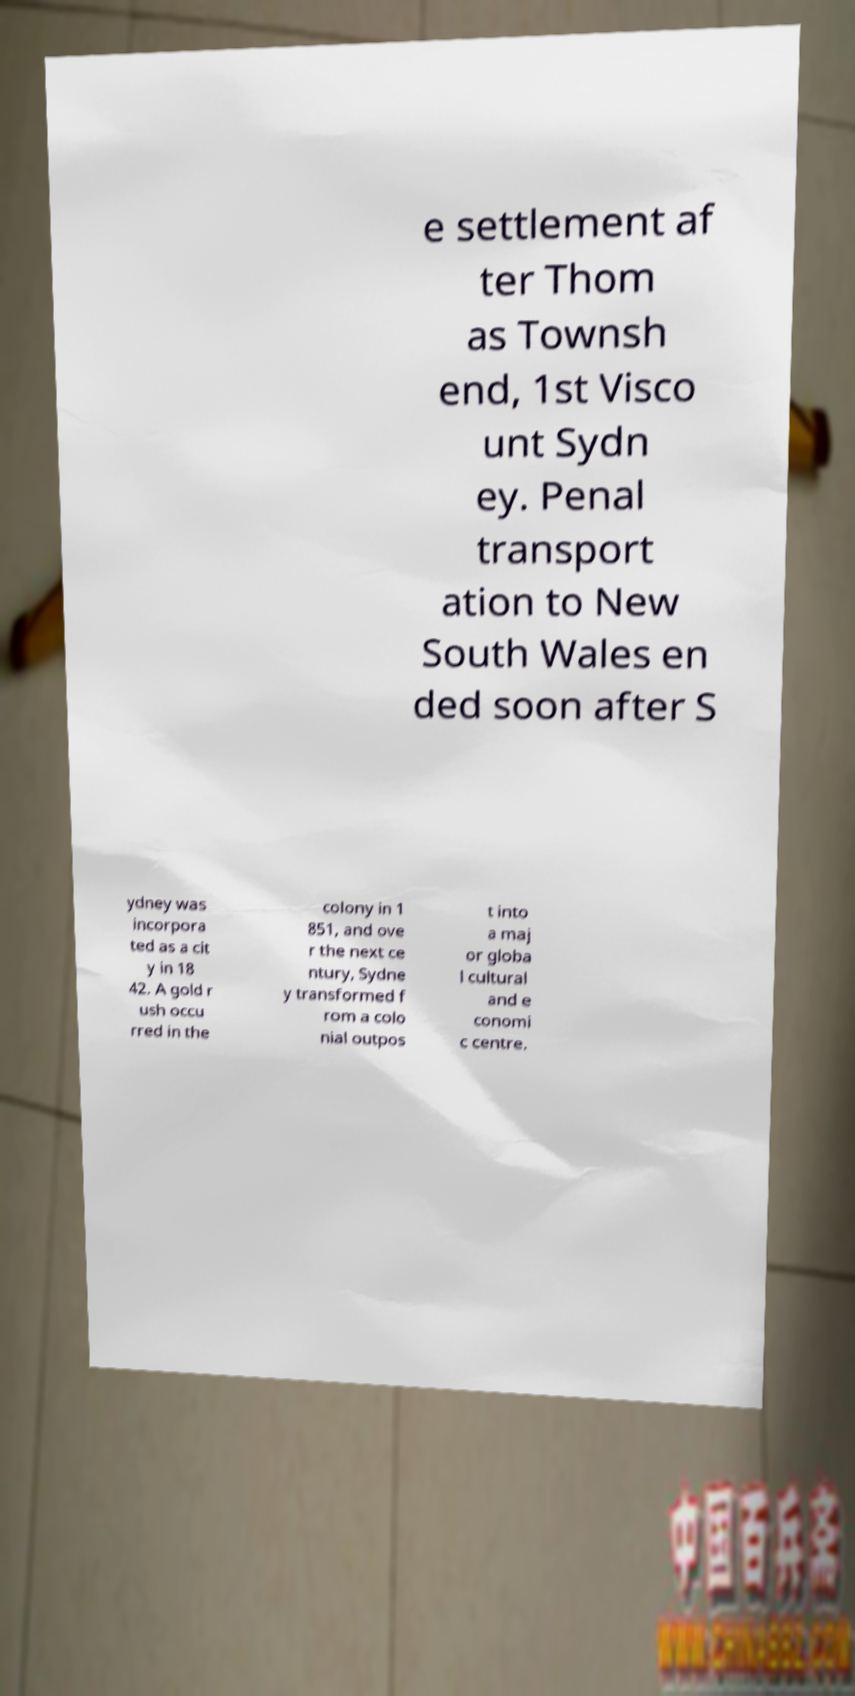For documentation purposes, I need the text within this image transcribed. Could you provide that? e settlement af ter Thom as Townsh end, 1st Visco unt Sydn ey. Penal transport ation to New South Wales en ded soon after S ydney was incorpora ted as a cit y in 18 42. A gold r ush occu rred in the colony in 1 851, and ove r the next ce ntury, Sydne y transformed f rom a colo nial outpos t into a maj or globa l cultural and e conomi c centre. 